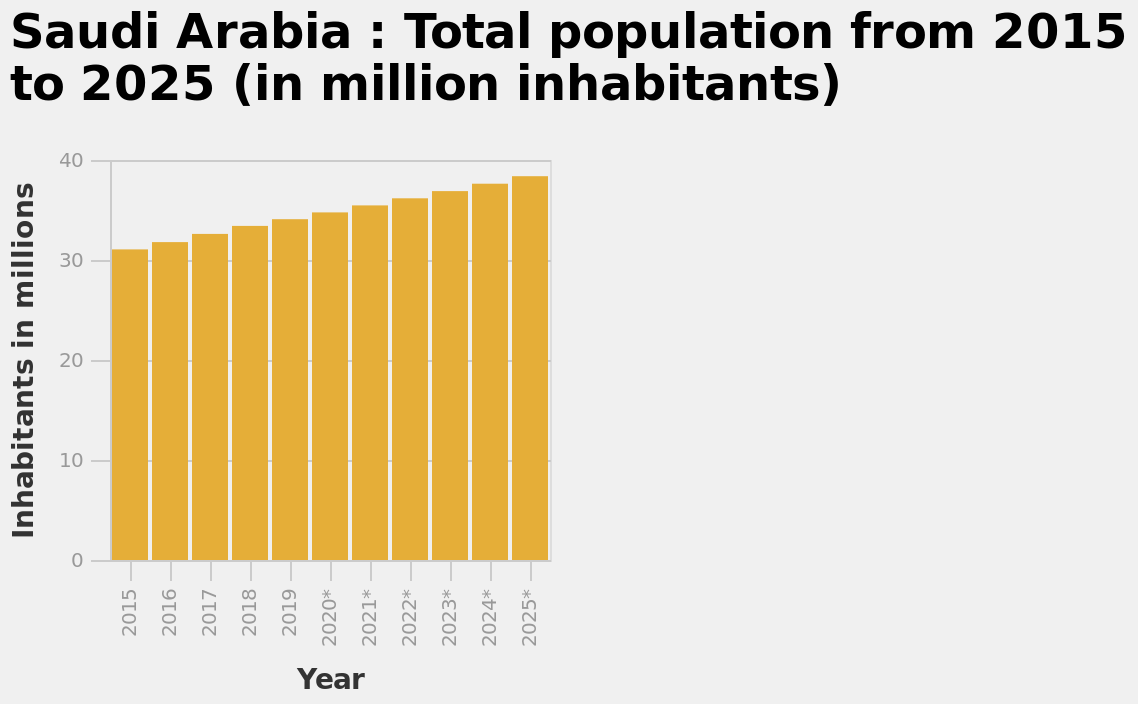<image>
What is the label on the y-axis of the bar plot?  The y-axis of the bar plot is labeled "Inhabitants in millions". Is the population increasing or decreasing over the years?  The population is steadily increasing over the years. What is the speculation made from analyzing the graph?  From analyzing the graph, it appears that the future years have been predicted based on the data gathered during the first few years. How is the population data represented on the y-axis of the bar plot? The population data on the y-axis of the bar plot is represented in millions of inhabitants. 